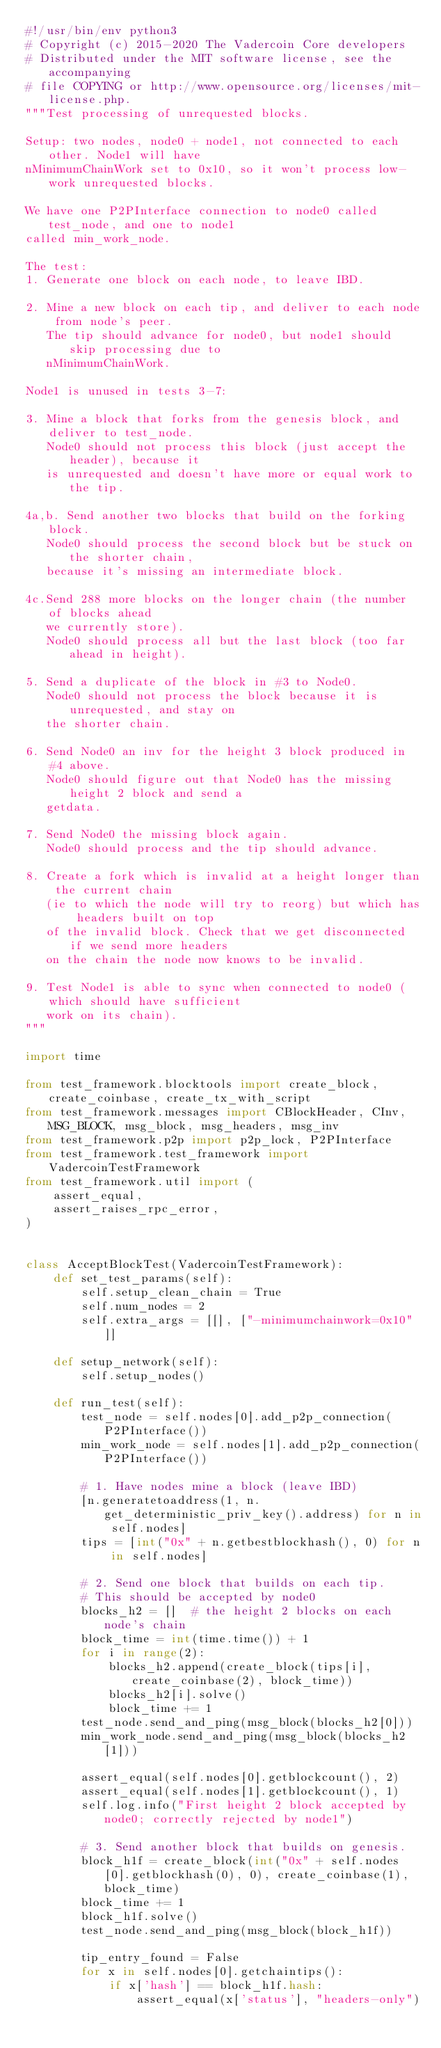Convert code to text. <code><loc_0><loc_0><loc_500><loc_500><_Python_>#!/usr/bin/env python3
# Copyright (c) 2015-2020 The Vadercoin Core developers
# Distributed under the MIT software license, see the accompanying
# file COPYING or http://www.opensource.org/licenses/mit-license.php.
"""Test processing of unrequested blocks.

Setup: two nodes, node0 + node1, not connected to each other. Node1 will have
nMinimumChainWork set to 0x10, so it won't process low-work unrequested blocks.

We have one P2PInterface connection to node0 called test_node, and one to node1
called min_work_node.

The test:
1. Generate one block on each node, to leave IBD.

2. Mine a new block on each tip, and deliver to each node from node's peer.
   The tip should advance for node0, but node1 should skip processing due to
   nMinimumChainWork.

Node1 is unused in tests 3-7:

3. Mine a block that forks from the genesis block, and deliver to test_node.
   Node0 should not process this block (just accept the header), because it
   is unrequested and doesn't have more or equal work to the tip.

4a,b. Send another two blocks that build on the forking block.
   Node0 should process the second block but be stuck on the shorter chain,
   because it's missing an intermediate block.

4c.Send 288 more blocks on the longer chain (the number of blocks ahead
   we currently store).
   Node0 should process all but the last block (too far ahead in height).

5. Send a duplicate of the block in #3 to Node0.
   Node0 should not process the block because it is unrequested, and stay on
   the shorter chain.

6. Send Node0 an inv for the height 3 block produced in #4 above.
   Node0 should figure out that Node0 has the missing height 2 block and send a
   getdata.

7. Send Node0 the missing block again.
   Node0 should process and the tip should advance.

8. Create a fork which is invalid at a height longer than the current chain
   (ie to which the node will try to reorg) but which has headers built on top
   of the invalid block. Check that we get disconnected if we send more headers
   on the chain the node now knows to be invalid.

9. Test Node1 is able to sync when connected to node0 (which should have sufficient
   work on its chain).
"""

import time

from test_framework.blocktools import create_block, create_coinbase, create_tx_with_script
from test_framework.messages import CBlockHeader, CInv, MSG_BLOCK, msg_block, msg_headers, msg_inv
from test_framework.p2p import p2p_lock, P2PInterface
from test_framework.test_framework import VadercoinTestFramework
from test_framework.util import (
    assert_equal,
    assert_raises_rpc_error,
)


class AcceptBlockTest(VadercoinTestFramework):
    def set_test_params(self):
        self.setup_clean_chain = True
        self.num_nodes = 2
        self.extra_args = [[], ["-minimumchainwork=0x10"]]

    def setup_network(self):
        self.setup_nodes()

    def run_test(self):
        test_node = self.nodes[0].add_p2p_connection(P2PInterface())
        min_work_node = self.nodes[1].add_p2p_connection(P2PInterface())

        # 1. Have nodes mine a block (leave IBD)
        [n.generatetoaddress(1, n.get_deterministic_priv_key().address) for n in self.nodes]
        tips = [int("0x" + n.getbestblockhash(), 0) for n in self.nodes]

        # 2. Send one block that builds on each tip.
        # This should be accepted by node0
        blocks_h2 = []  # the height 2 blocks on each node's chain
        block_time = int(time.time()) + 1
        for i in range(2):
            blocks_h2.append(create_block(tips[i], create_coinbase(2), block_time))
            blocks_h2[i].solve()
            block_time += 1
        test_node.send_and_ping(msg_block(blocks_h2[0]))
        min_work_node.send_and_ping(msg_block(blocks_h2[1]))

        assert_equal(self.nodes[0].getblockcount(), 2)
        assert_equal(self.nodes[1].getblockcount(), 1)
        self.log.info("First height 2 block accepted by node0; correctly rejected by node1")

        # 3. Send another block that builds on genesis.
        block_h1f = create_block(int("0x" + self.nodes[0].getblockhash(0), 0), create_coinbase(1), block_time)
        block_time += 1
        block_h1f.solve()
        test_node.send_and_ping(msg_block(block_h1f))

        tip_entry_found = False
        for x in self.nodes[0].getchaintips():
            if x['hash'] == block_h1f.hash:
                assert_equal(x['status'], "headers-only")</code> 